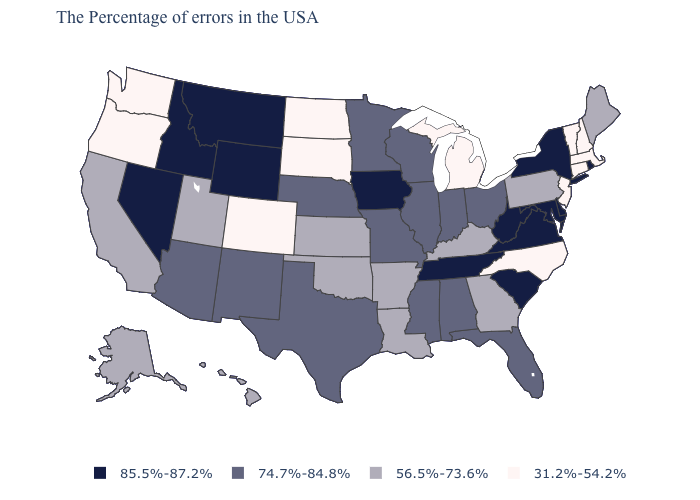Name the states that have a value in the range 85.5%-87.2%?
Concise answer only. Rhode Island, New York, Delaware, Maryland, Virginia, South Carolina, West Virginia, Tennessee, Iowa, Wyoming, Montana, Idaho, Nevada. What is the value of New Jersey?
Write a very short answer. 31.2%-54.2%. What is the value of Idaho?
Write a very short answer. 85.5%-87.2%. Does the map have missing data?
Answer briefly. No. What is the value of Virginia?
Short answer required. 85.5%-87.2%. Does Louisiana have the highest value in the South?
Answer briefly. No. Name the states that have a value in the range 74.7%-84.8%?
Short answer required. Ohio, Florida, Indiana, Alabama, Wisconsin, Illinois, Mississippi, Missouri, Minnesota, Nebraska, Texas, New Mexico, Arizona. Which states have the lowest value in the Northeast?
Concise answer only. Massachusetts, New Hampshire, Vermont, Connecticut, New Jersey. Does Florida have the highest value in the USA?
Write a very short answer. No. Which states have the highest value in the USA?
Concise answer only. Rhode Island, New York, Delaware, Maryland, Virginia, South Carolina, West Virginia, Tennessee, Iowa, Wyoming, Montana, Idaho, Nevada. What is the value of Georgia?
Answer briefly. 56.5%-73.6%. Among the states that border South Dakota , which have the lowest value?
Be succinct. North Dakota. What is the highest value in the West ?
Give a very brief answer. 85.5%-87.2%. What is the highest value in the Northeast ?
Short answer required. 85.5%-87.2%. Name the states that have a value in the range 56.5%-73.6%?
Concise answer only. Maine, Pennsylvania, Georgia, Kentucky, Louisiana, Arkansas, Kansas, Oklahoma, Utah, California, Alaska, Hawaii. 